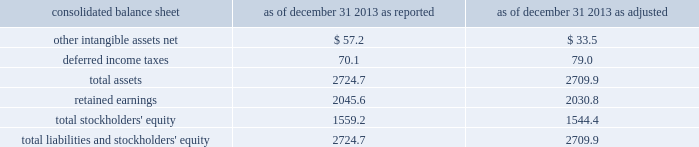Edwards lifesciences corporation notes to consolidated financial statements ( continued ) 2 .
Summary of significant accounting policies ( continued ) interim periods therein .
The new guidance can be applied retrospectively to each prior reporting period presented or retrospectively with the cumulative effect of the change recognized at the date of the initial application .
The company is currently assessing the impact this guidance will have on its consolidated financial statements , and has not yet selected a transition method .
Change in accounting principle effective january 1 , 2014 , the company changed its method of accounting for certain intellectual property litigation expenses related to the defense and enforcement of its issued patents .
Previously , the company capitalized these legal costs if a favorable outcome in the patent defense was determined to be probable , and amortized the capitalized legal costs over the life of the related patent .
As of december 31 , 2013 , the company had remaining unamortized capitalized legal costs of $ 23.7 million , which , under the previous accounting method , would have been amortized through 2021 .
Under the new method of accounting , these legal costs are expensed in the period they are incurred .
The company has retrospectively adjusted the comparative financial statements of prior periods to apply this new method of accounting .
The company believes this change in accounting principle is preferable because ( 1 ) as more competitors enter the company 2019s key product markets and the threat of complex intellectual property litigation across multiple jurisdictions increases , it will become more difficult for the company to accurately assess the probability of a favorable outcome in such litigation , and ( 2 ) it will enhance the comparability of the company 2019s financial results with those of its peer group because it is the predominant accounting practice in the company 2019s industry .
The accompanying consolidated financial statements and related notes have been adjusted to reflect the impact of this change retrospectively to all prior periods presented .
The cumulative effect of the change in accounting principle was a decrease in retained earnings of $ 10.5 million as of january 1 , 2012 .
The tables present the effects of the retrospective application of the change in accounting principle ( in millions ) : .

What was the affect of the change in accounting principles on other intangible assets net in millions? 
Rationale: size of the write down due to change
Computations: (33.5 - 57.2)
Answer: -23.7. 